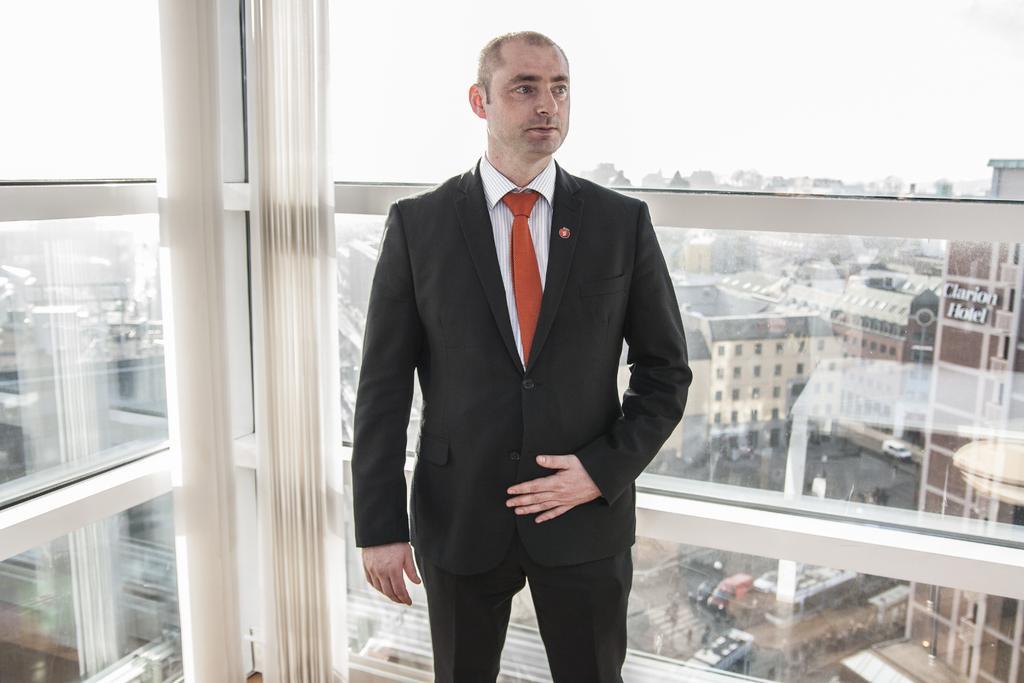In one or two sentences, can you explain what this image depicts? In this image there is a person standing ,and in the background there are buildings, trees, vehicles,sky. 